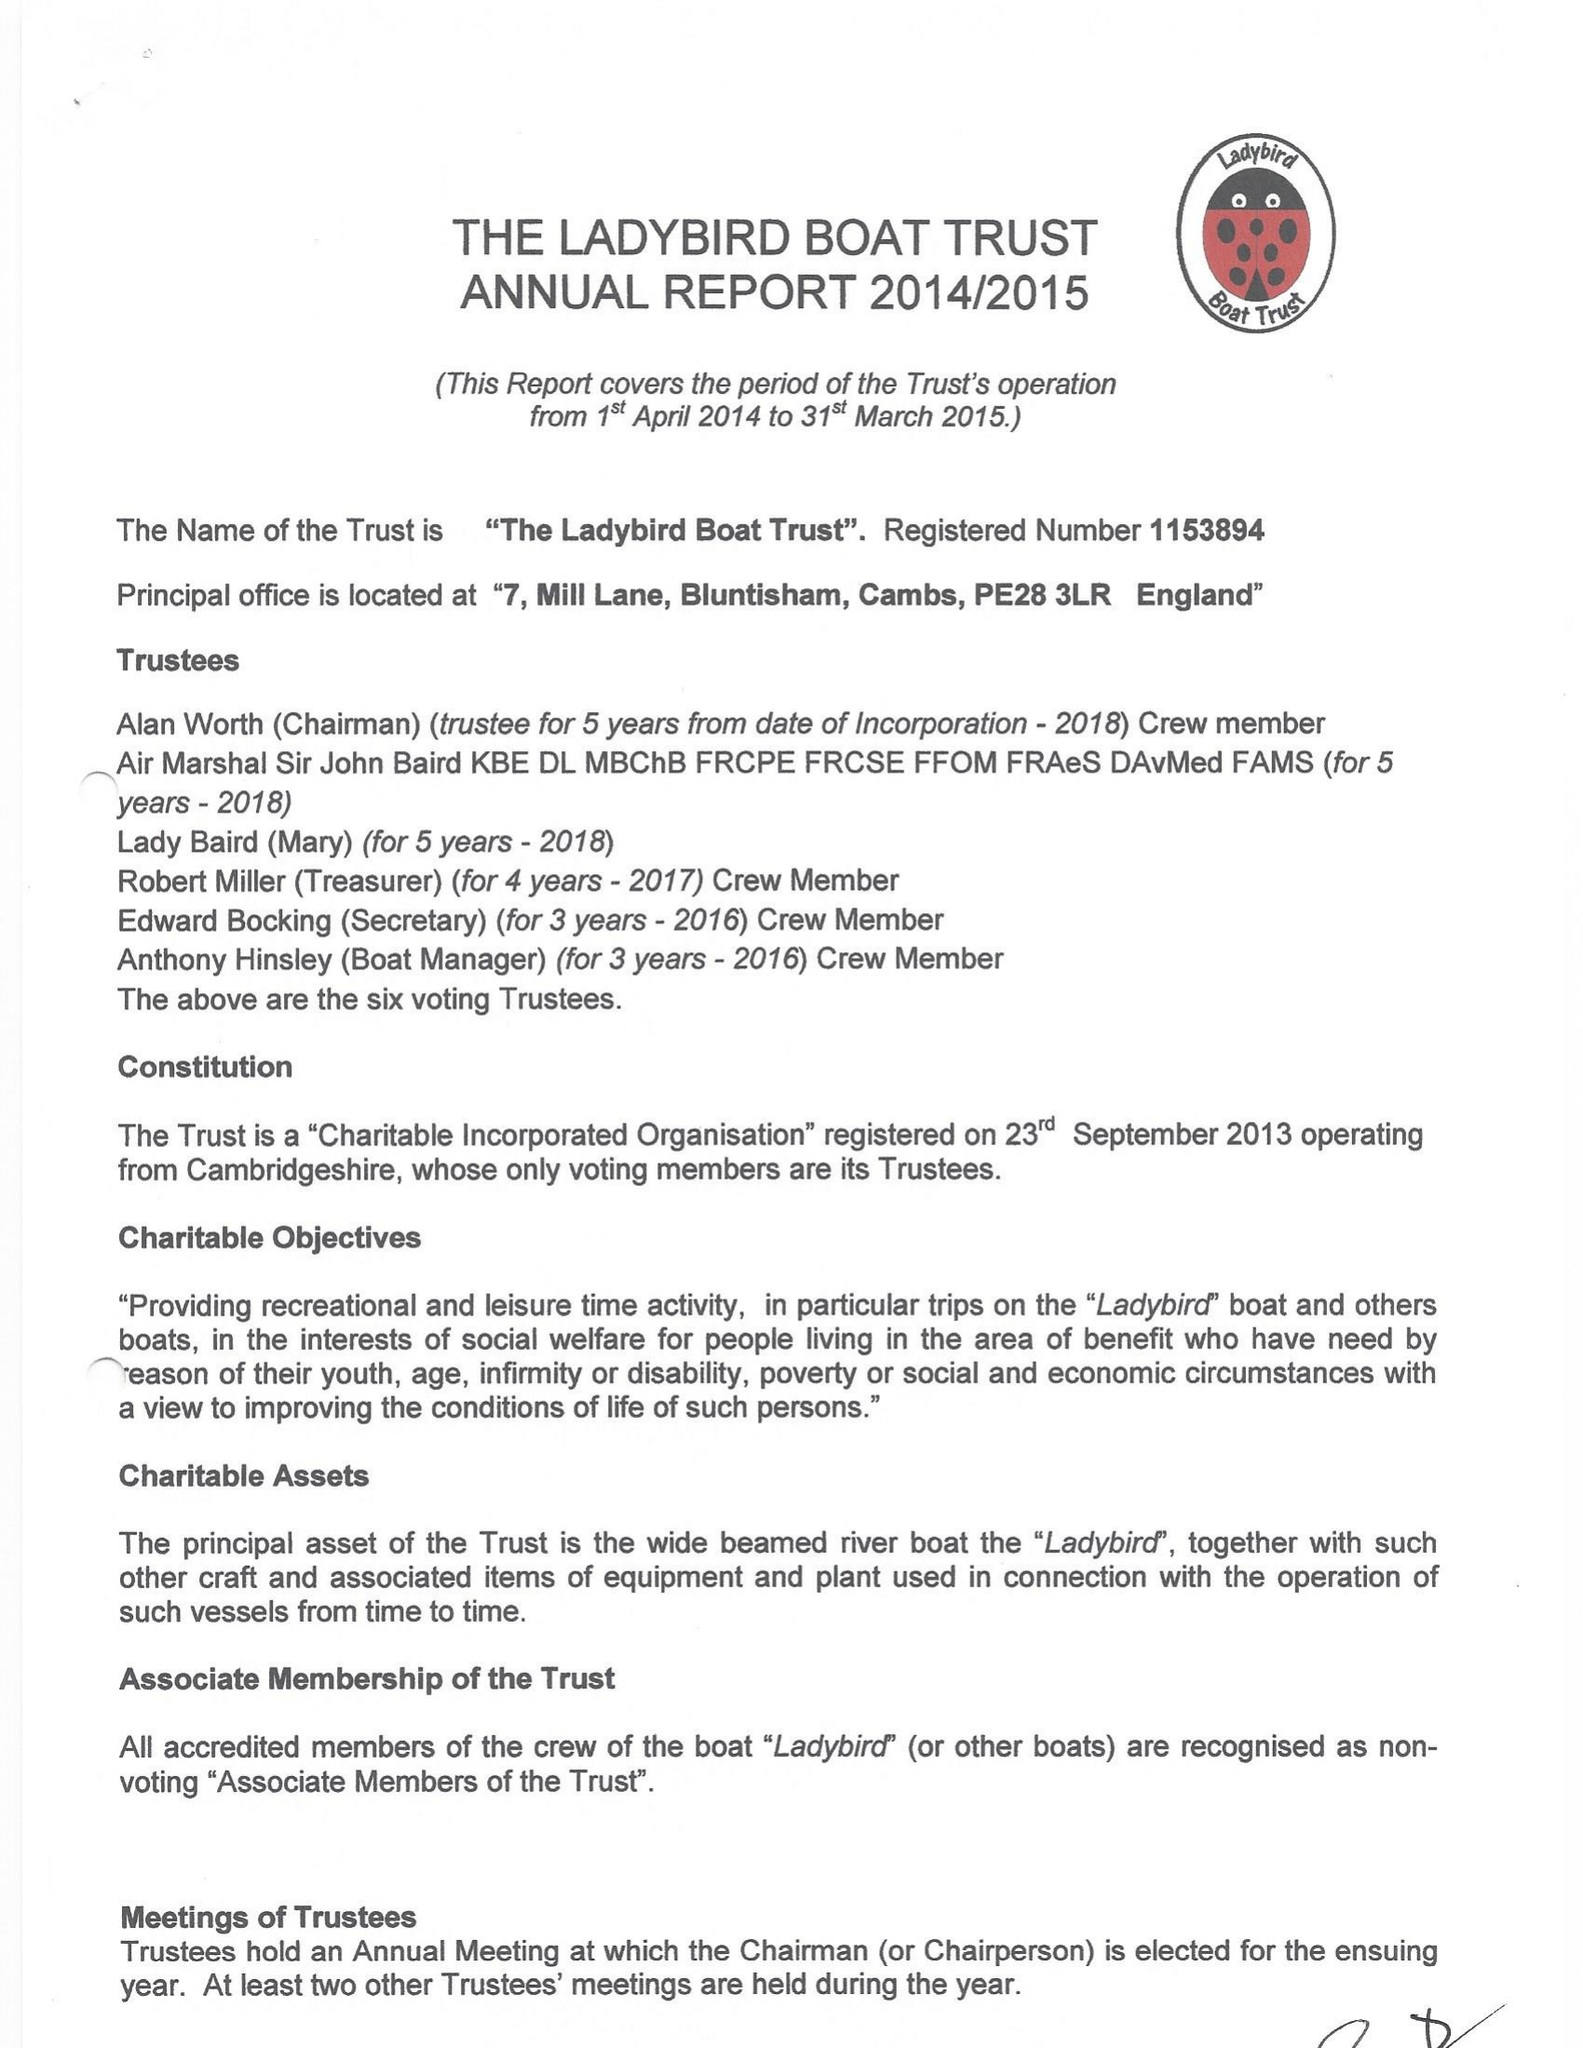What is the value for the income_annually_in_british_pounds?
Answer the question using a single word or phrase. 32846.00 